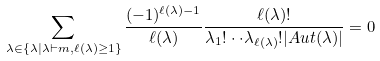<formula> <loc_0><loc_0><loc_500><loc_500>\sum _ { \lambda \in \{ \lambda | \lambda \vdash m , \ell ( \lambda ) \geq 1 \} } \frac { ( - 1 ) ^ { \ell ( \lambda ) - 1 } } { \ell ( \lambda ) } \frac { \ell ( \lambda ) ! } { \lambda _ { 1 } ! \cdot \cdot \lambda _ { \ell ( \lambda ) } ! | A u t ( \lambda ) | } = 0</formula> 